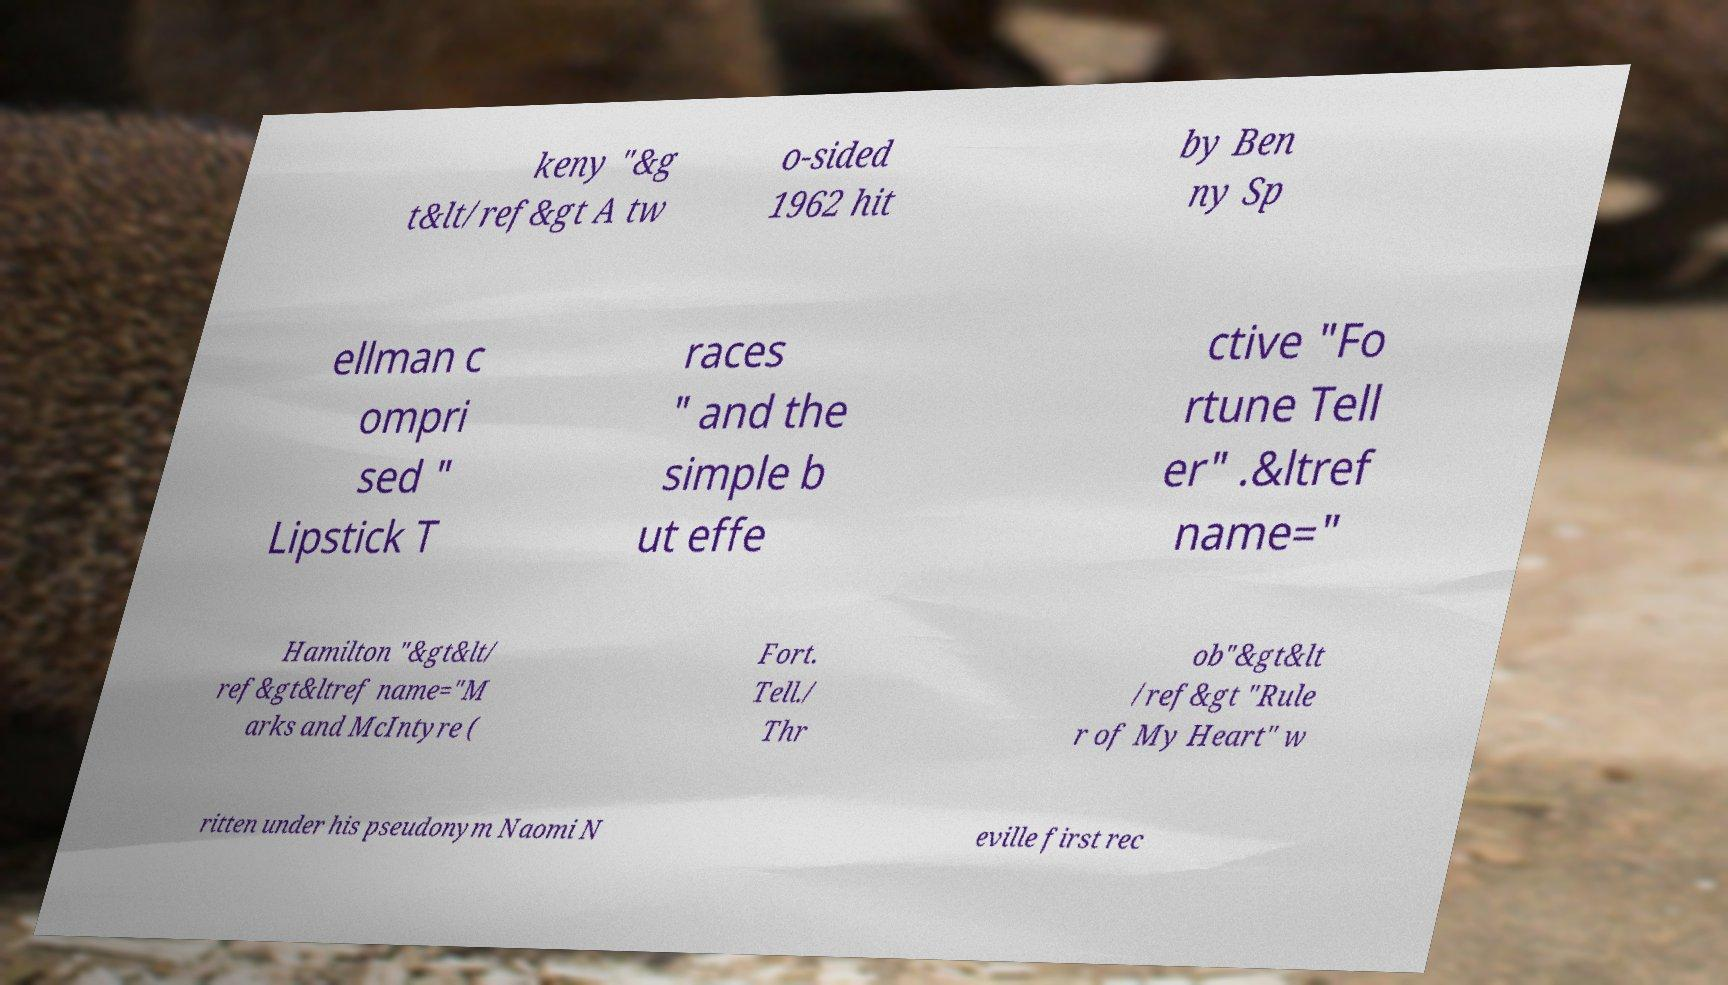Please identify and transcribe the text found in this image. keny "&g t&lt/ref&gt A tw o-sided 1962 hit by Ben ny Sp ellman c ompri sed " Lipstick T races " and the simple b ut effe ctive "Fo rtune Tell er" .&ltref name=" Hamilton "&gt&lt/ ref&gt&ltref name="M arks and McIntyre ( Fort. Tell./ Thr ob"&gt&lt /ref&gt "Rule r of My Heart" w ritten under his pseudonym Naomi N eville first rec 